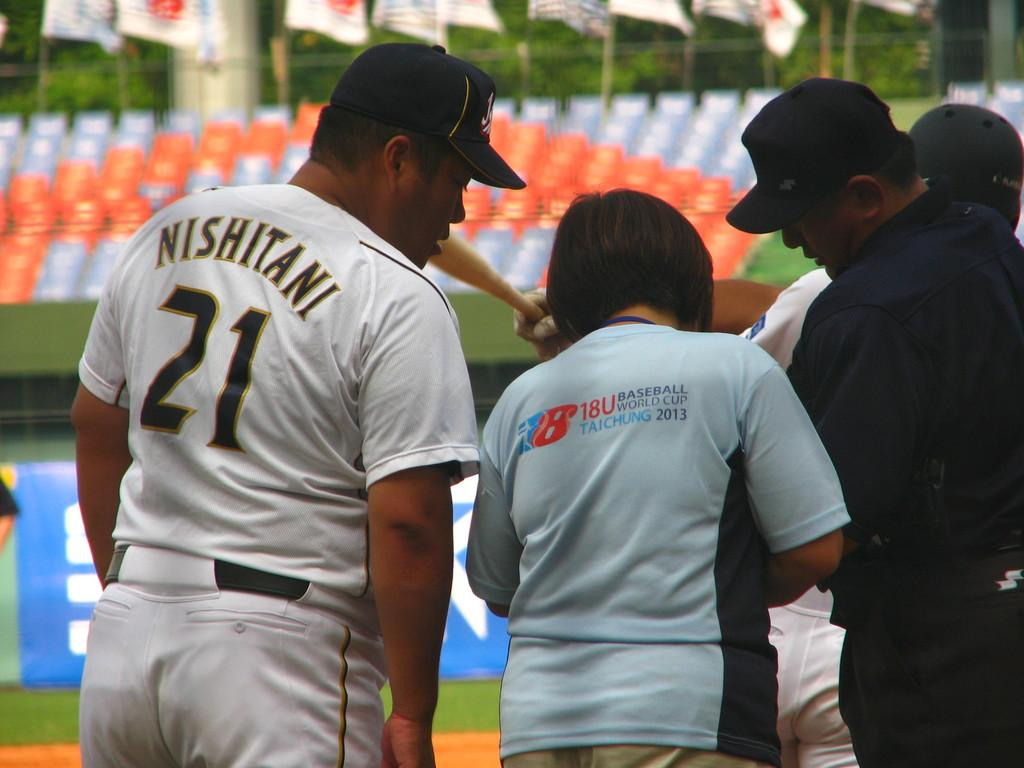<image>
Write a terse but informative summary of the picture. A heavyset baseball player wears a number 21 uniform. 